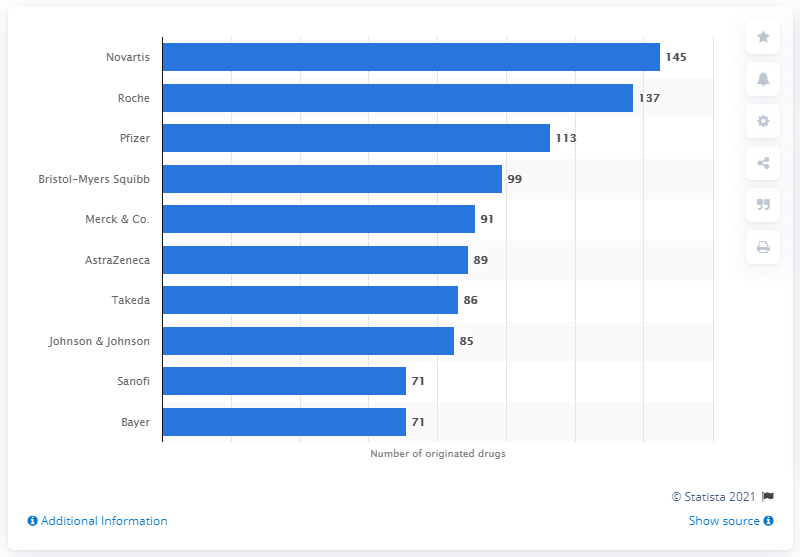List a handful of essential elements in this visual. In 2021, Novartis AG had a total of 145 drugs in its portfolio. 